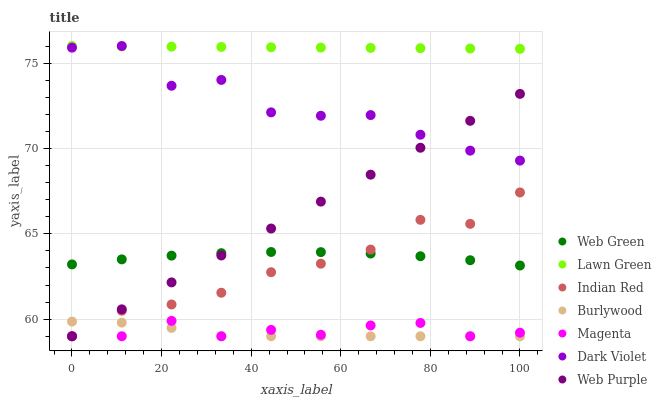Does Burlywood have the minimum area under the curve?
Answer yes or no. Yes. Does Lawn Green have the maximum area under the curve?
Answer yes or no. Yes. Does Dark Violet have the minimum area under the curve?
Answer yes or no. No. Does Dark Violet have the maximum area under the curve?
Answer yes or no. No. Is Web Purple the smoothest?
Answer yes or no. Yes. Is Dark Violet the roughest?
Answer yes or no. Yes. Is Burlywood the smoothest?
Answer yes or no. No. Is Burlywood the roughest?
Answer yes or no. No. Does Burlywood have the lowest value?
Answer yes or no. Yes. Does Dark Violet have the lowest value?
Answer yes or no. No. Does Dark Violet have the highest value?
Answer yes or no. Yes. Does Burlywood have the highest value?
Answer yes or no. No. Is Burlywood less than Dark Violet?
Answer yes or no. Yes. Is Dark Violet greater than Burlywood?
Answer yes or no. Yes. Does Dark Violet intersect Web Purple?
Answer yes or no. Yes. Is Dark Violet less than Web Purple?
Answer yes or no. No. Is Dark Violet greater than Web Purple?
Answer yes or no. No. Does Burlywood intersect Dark Violet?
Answer yes or no. No. 